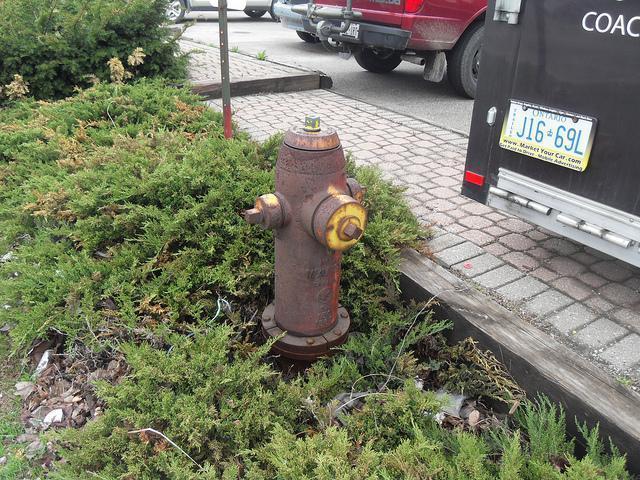Where is the fire hydrant mounted?
From the following four choices, select the correct answer to address the question.
Options: Tree, landscape, sidewalk, parking lot. Landscape. 